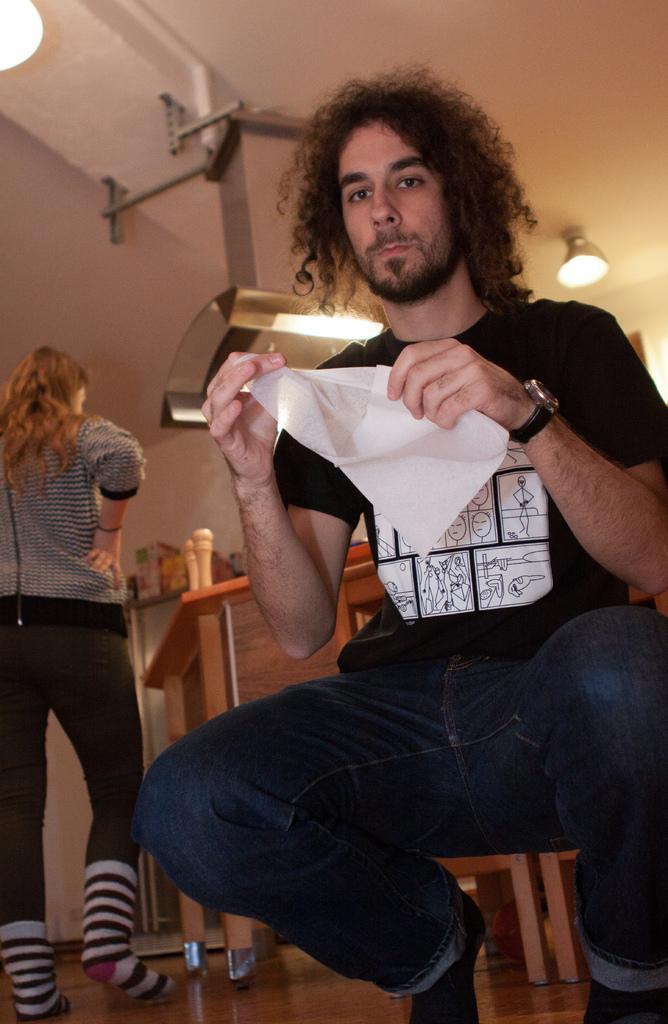Could you give a brief overview of what you see in this image? In this picture there is a man who is wearing t-shirt, match, jeans and socks. He is holding paper. On the left there is a woman who is wearing hoodie, trouser and socks. She is standing near to the table. On the table we can see some objects. On the top we can see exhaust duct and light. 